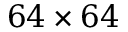<formula> <loc_0><loc_0><loc_500><loc_500>6 4 \times 6 4</formula> 